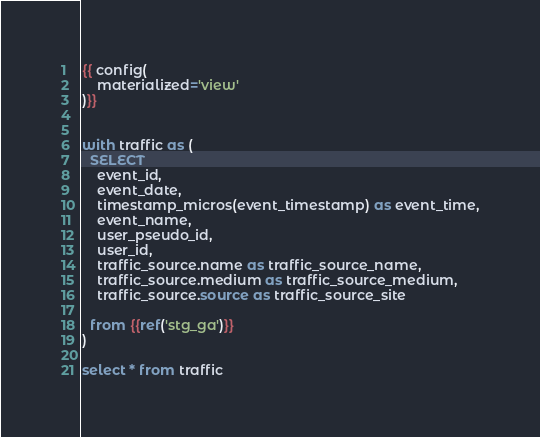<code> <loc_0><loc_0><loc_500><loc_500><_SQL_>
{{ config(
    materialized='view'
)}}


with traffic as (
  SELECT
    event_id,
    event_date,
    timestamp_micros(event_timestamp) as event_time,
    event_name,
    user_pseudo_id,
    user_id,
    traffic_source.name as traffic_source_name,
    traffic_source.medium as traffic_source_medium,
    traffic_source.source as traffic_source_site

  from {{ref('stg_ga')}}
)

select * from traffic

</code> 